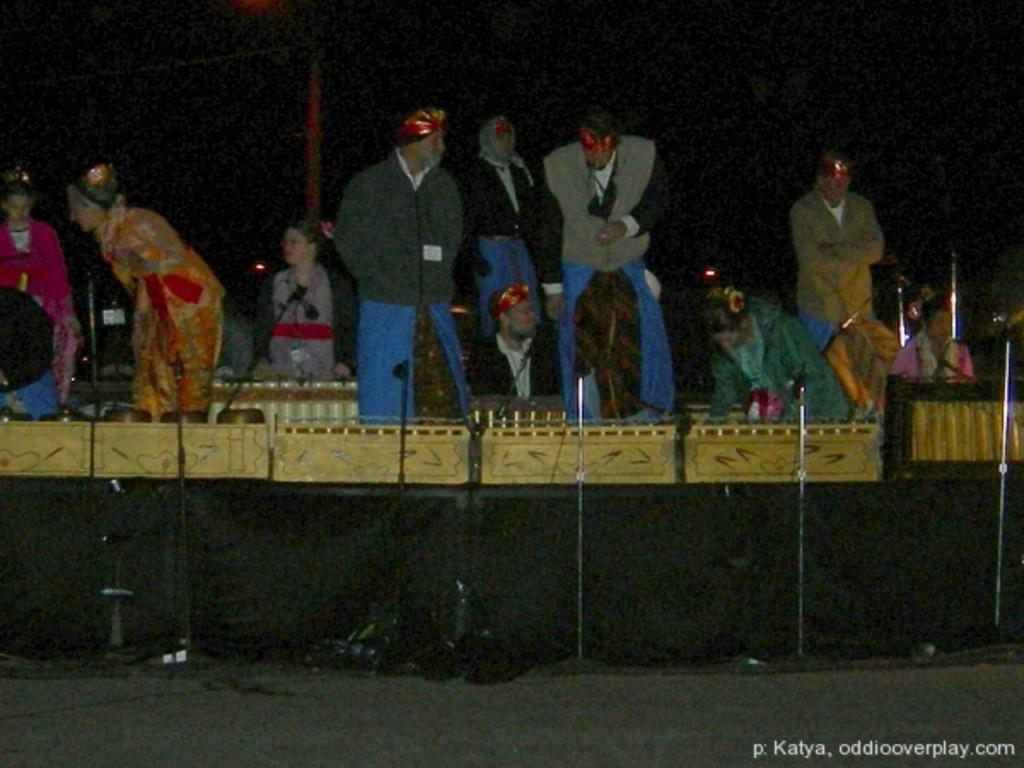What are the people in the image doing? There are people standing and sitting in the image. Can you describe the positions of the people in the image? Some people are standing, while others are sitting. What type of mitten is being worn by the person standing in the image? There is no mitten visible in the image, as the focus is on the people standing and sitting. 